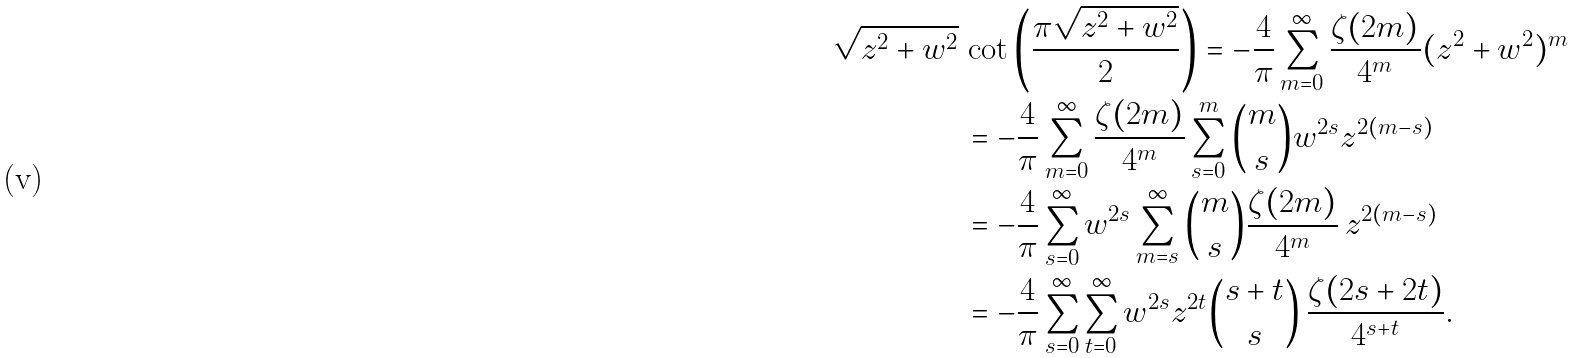<formula> <loc_0><loc_0><loc_500><loc_500>\sqrt { z ^ { 2 } + w ^ { 2 } } \, & \cot \left ( \frac { \pi \sqrt { z ^ { 2 } + w ^ { 2 } } } { 2 } \right ) = - \frac { 4 } { \pi } \sum _ { m = 0 } ^ { \infty } \frac { \zeta ( 2 m ) } { 4 ^ { m } } ( z ^ { 2 } + w ^ { 2 } ) ^ { m } \\ & = - \frac { 4 } { \pi } \sum _ { m = 0 } ^ { \infty } \frac { \zeta ( 2 m ) } { 4 ^ { m } } \sum _ { s = 0 } ^ { m } \binom { m } { s } w ^ { 2 s } z ^ { 2 ( m - s ) } \\ & = - \frac { 4 } { \pi } \sum _ { s = 0 } ^ { \infty } w ^ { 2 s } \sum _ { m = s } ^ { \infty } \binom { m } { s } \frac { \zeta ( 2 m ) } { 4 ^ { m } } \, z ^ { 2 ( m - s ) } \\ & = - \frac { 4 } { \pi } \sum _ { s = 0 } ^ { \infty } \sum _ { t = 0 } ^ { \infty } w ^ { 2 s } z ^ { 2 t } \binom { s + t } { s } \, \frac { \zeta ( 2 s + 2 t ) } { 4 ^ { s + t } } .</formula> 